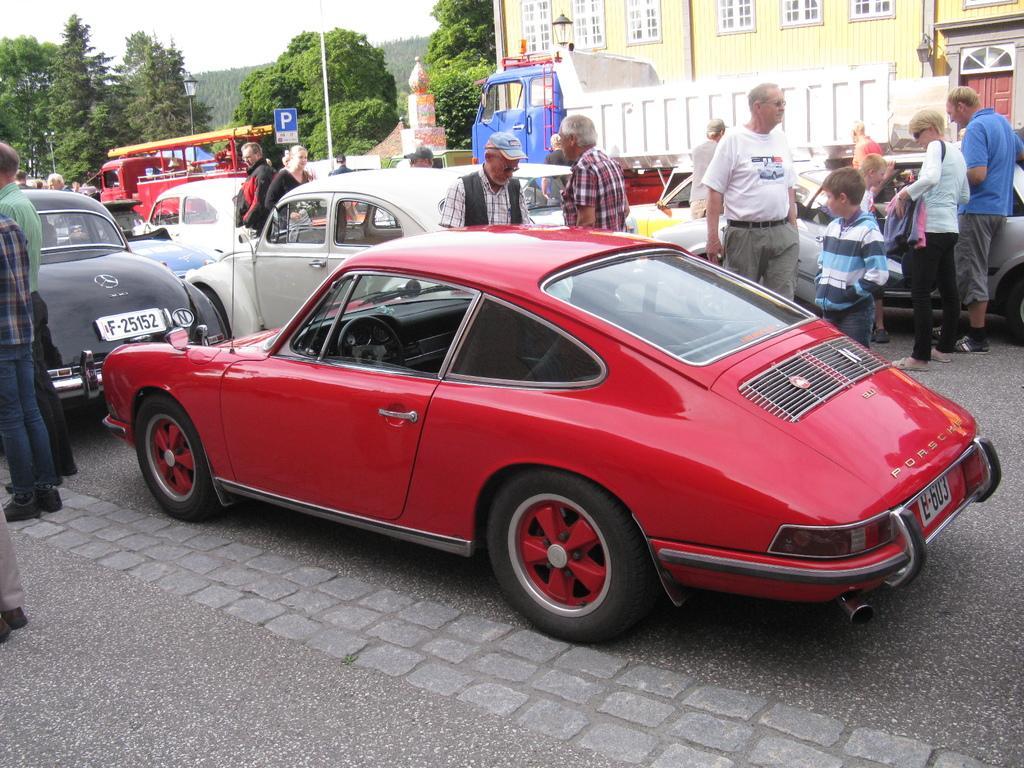Could you give a brief overview of what you see in this image? In the picture I can see vehicles and people standing on the road. In the background I can see a building, trees, the sky, poles and some other objects. 